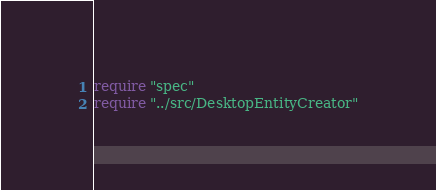Convert code to text. <code><loc_0><loc_0><loc_500><loc_500><_Crystal_>require "spec"
require "../src/DesktopEntityCreator"
</code> 